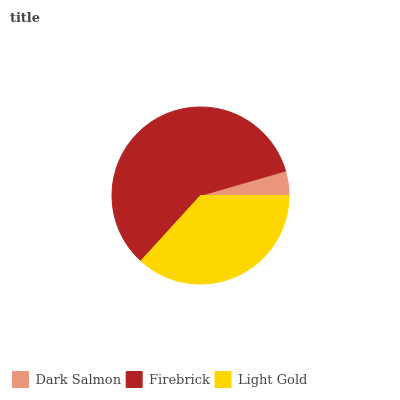Is Dark Salmon the minimum?
Answer yes or no. Yes. Is Firebrick the maximum?
Answer yes or no. Yes. Is Light Gold the minimum?
Answer yes or no. No. Is Light Gold the maximum?
Answer yes or no. No. Is Firebrick greater than Light Gold?
Answer yes or no. Yes. Is Light Gold less than Firebrick?
Answer yes or no. Yes. Is Light Gold greater than Firebrick?
Answer yes or no. No. Is Firebrick less than Light Gold?
Answer yes or no. No. Is Light Gold the high median?
Answer yes or no. Yes. Is Light Gold the low median?
Answer yes or no. Yes. Is Dark Salmon the high median?
Answer yes or no. No. Is Dark Salmon the low median?
Answer yes or no. No. 